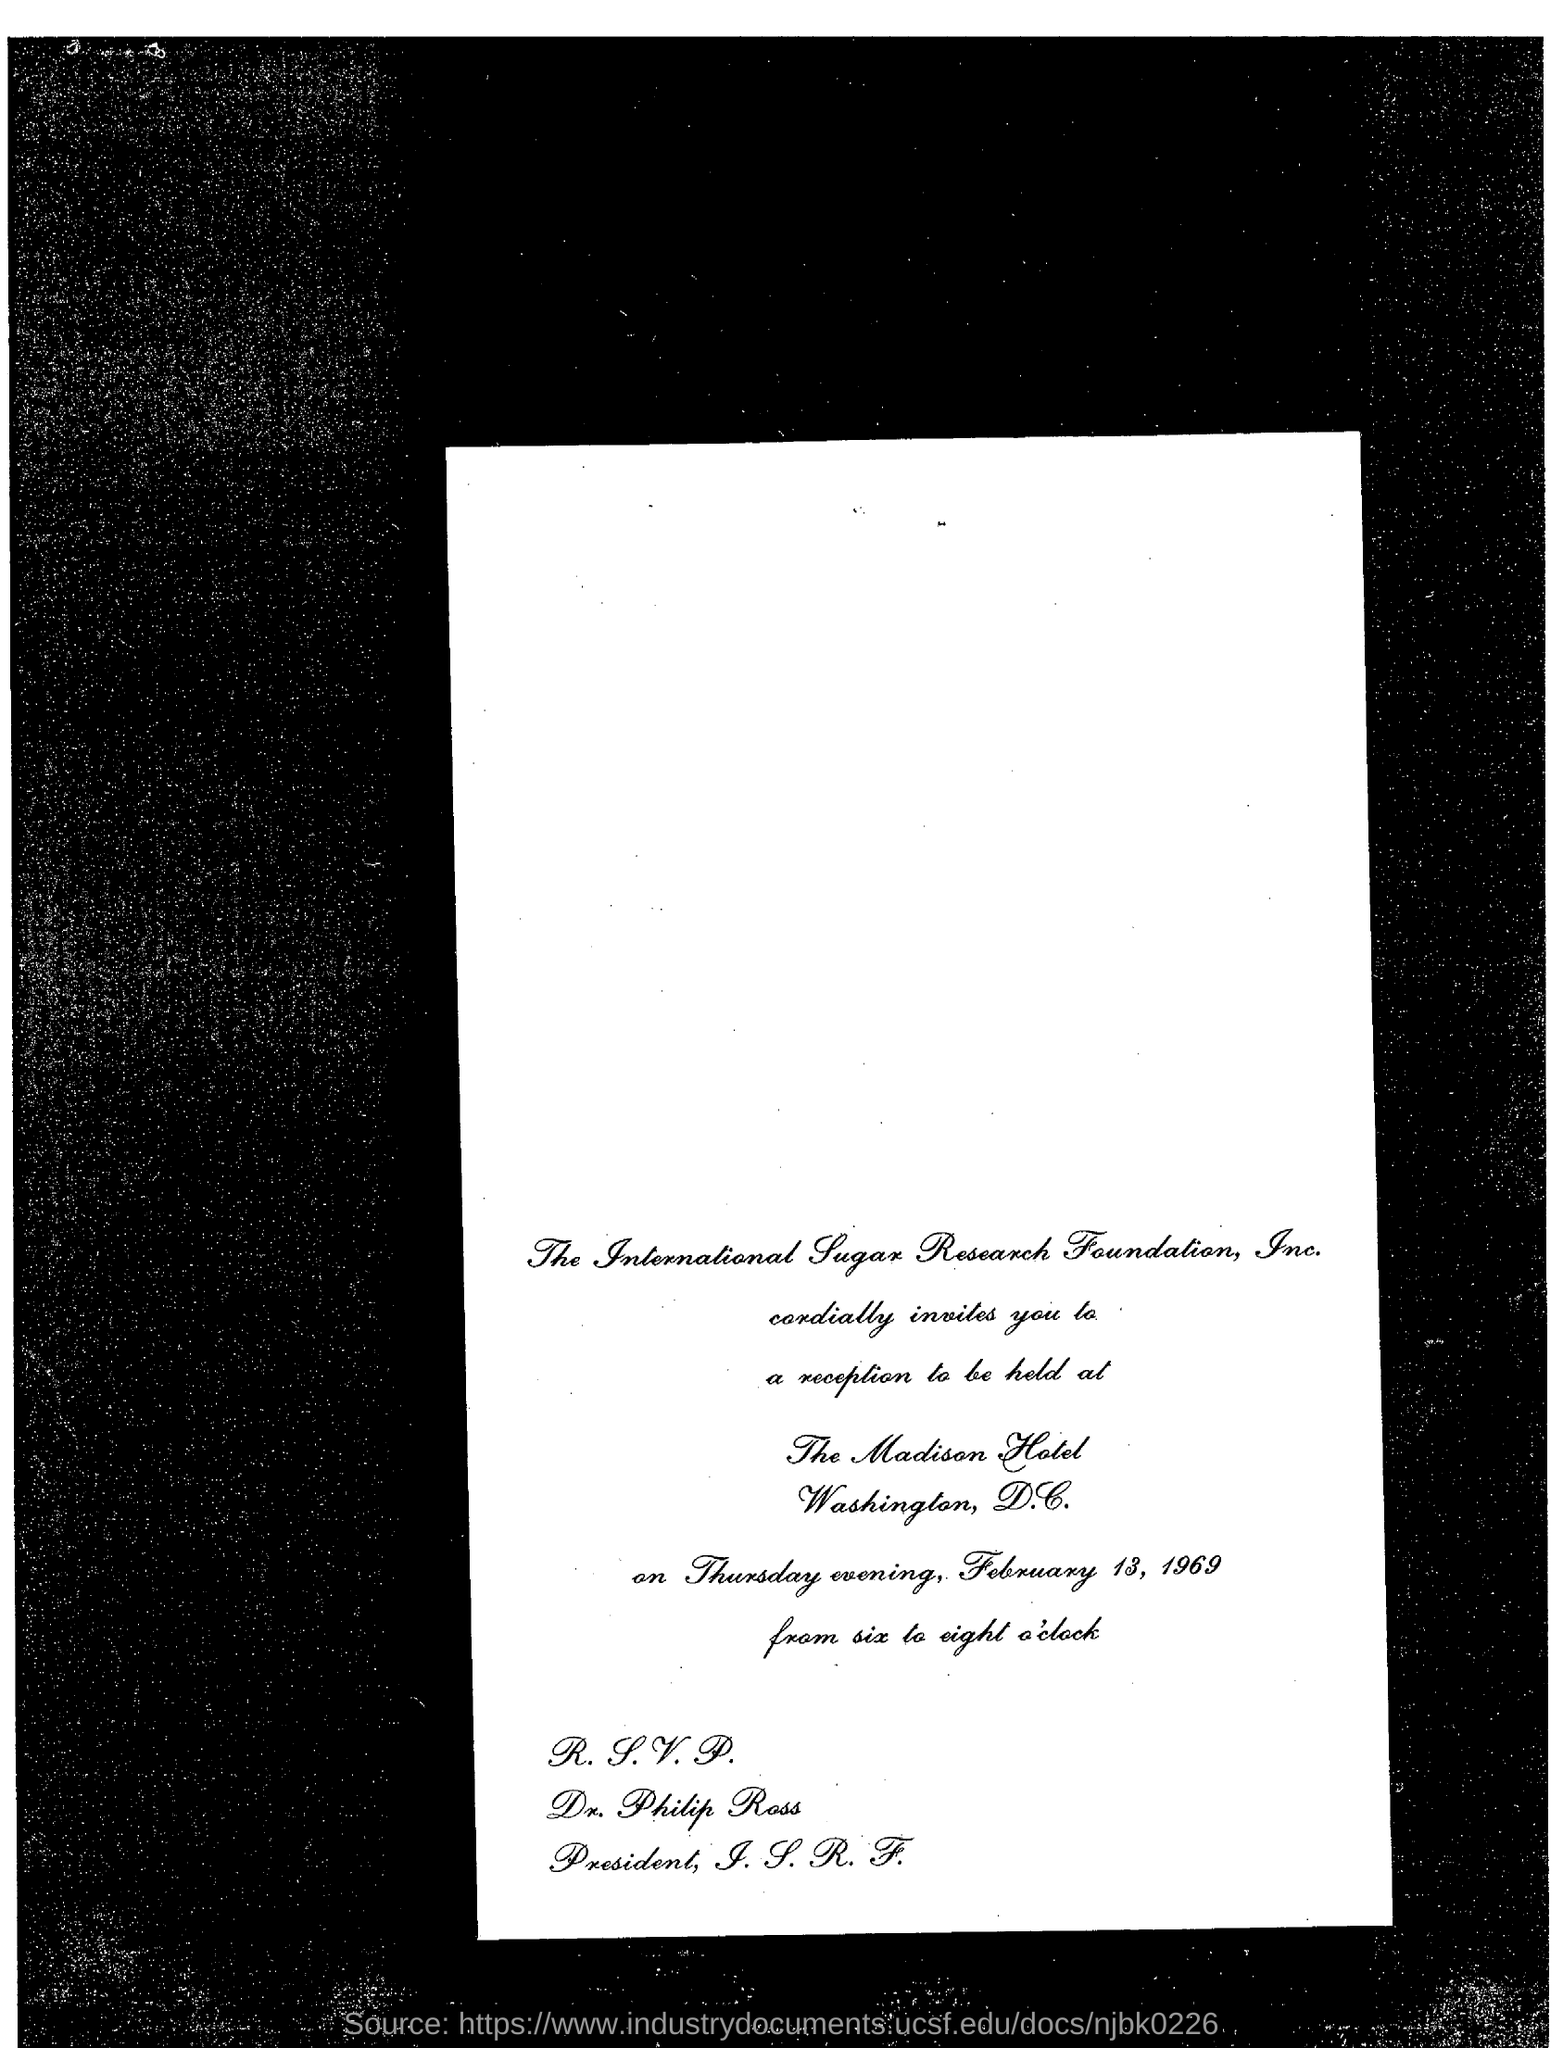Which company's name is mentioned?
Provide a succinct answer. The International Sugar Research Foundation, Inc. Where is the reception going to be held?
Offer a terse response. The Madison Hotel. 